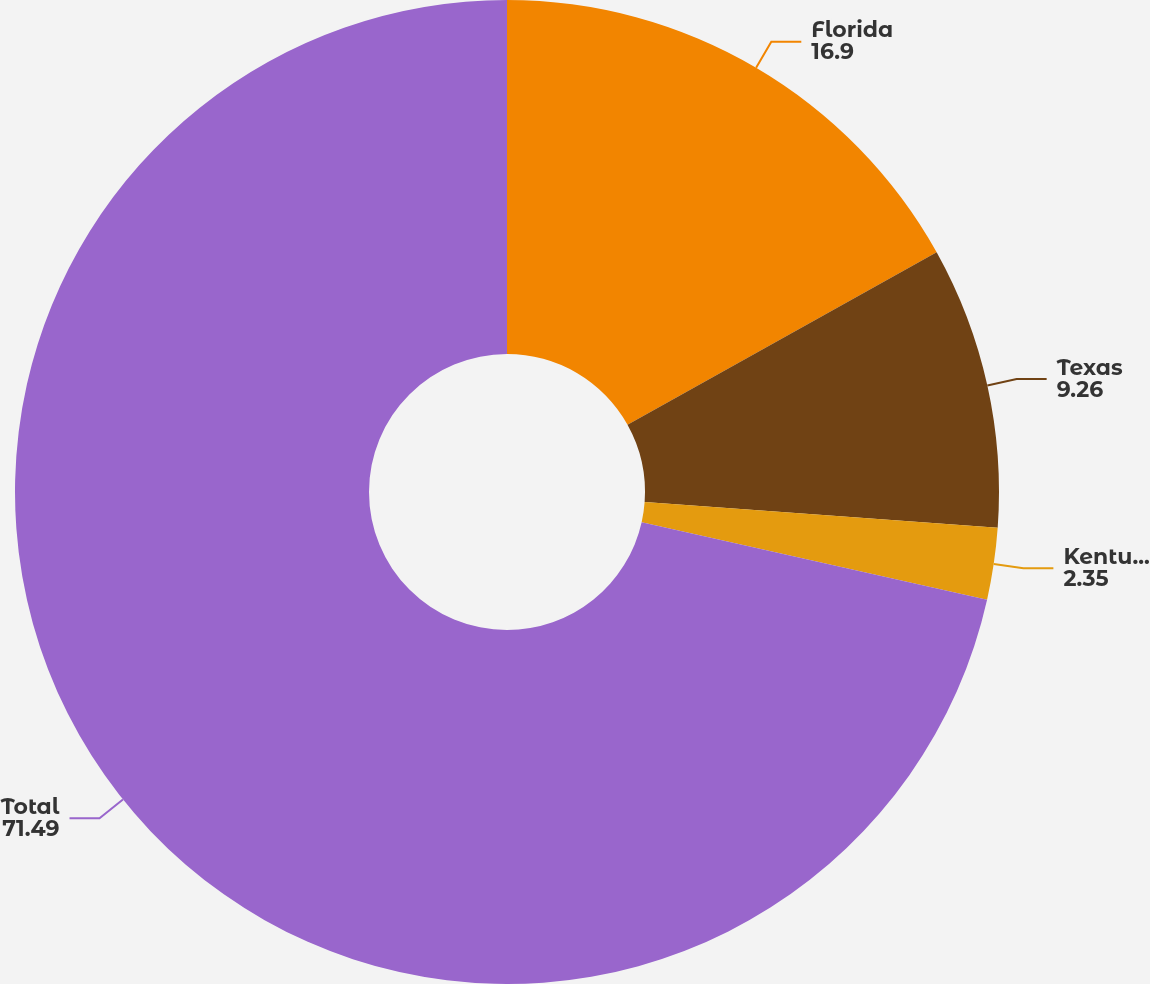Convert chart. <chart><loc_0><loc_0><loc_500><loc_500><pie_chart><fcel>Florida<fcel>Texas<fcel>Kentucky<fcel>Total<nl><fcel>16.9%<fcel>9.26%<fcel>2.35%<fcel>71.49%<nl></chart> 